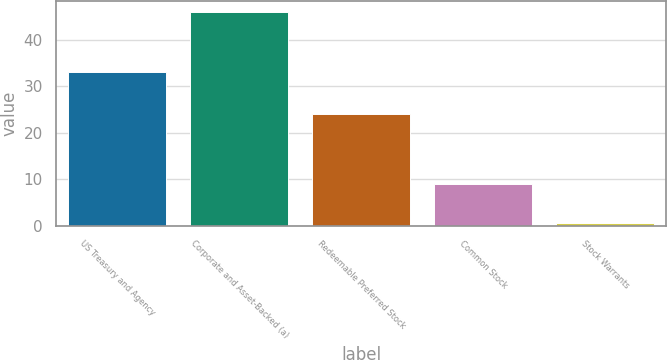Convert chart to OTSL. <chart><loc_0><loc_0><loc_500><loc_500><bar_chart><fcel>US Treasury and Agency<fcel>Corporate and Asset-Backed (a)<fcel>Redeemable Preferred Stock<fcel>Common Stock<fcel>Stock Warrants<nl><fcel>33<fcel>46<fcel>24<fcel>9<fcel>0.48<nl></chart> 